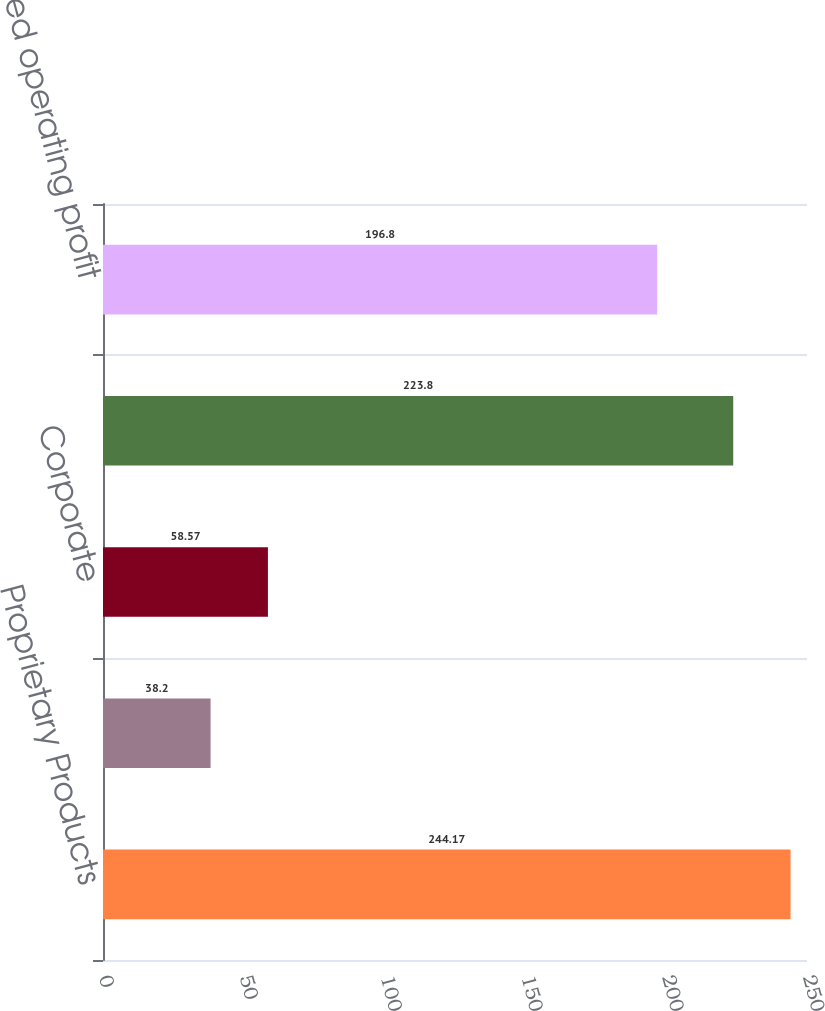<chart> <loc_0><loc_0><loc_500><loc_500><bar_chart><fcel>Proprietary Products<fcel>Contract-Manufactured Products<fcel>Corporate<fcel>Adjusted consolidated<fcel>Consolidated operating profit<nl><fcel>244.17<fcel>38.2<fcel>58.57<fcel>223.8<fcel>196.8<nl></chart> 